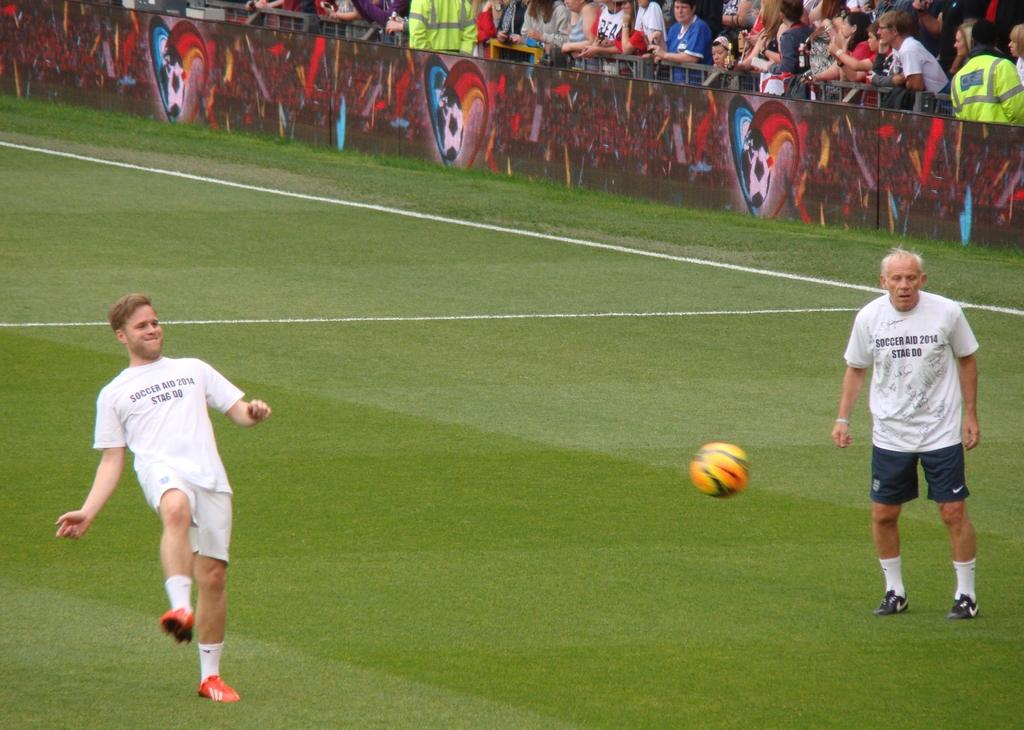<image>
Share a concise interpretation of the image provided. Two men on a soccer field are wearing shirts that say, 'Soccer Aid 2014'. 